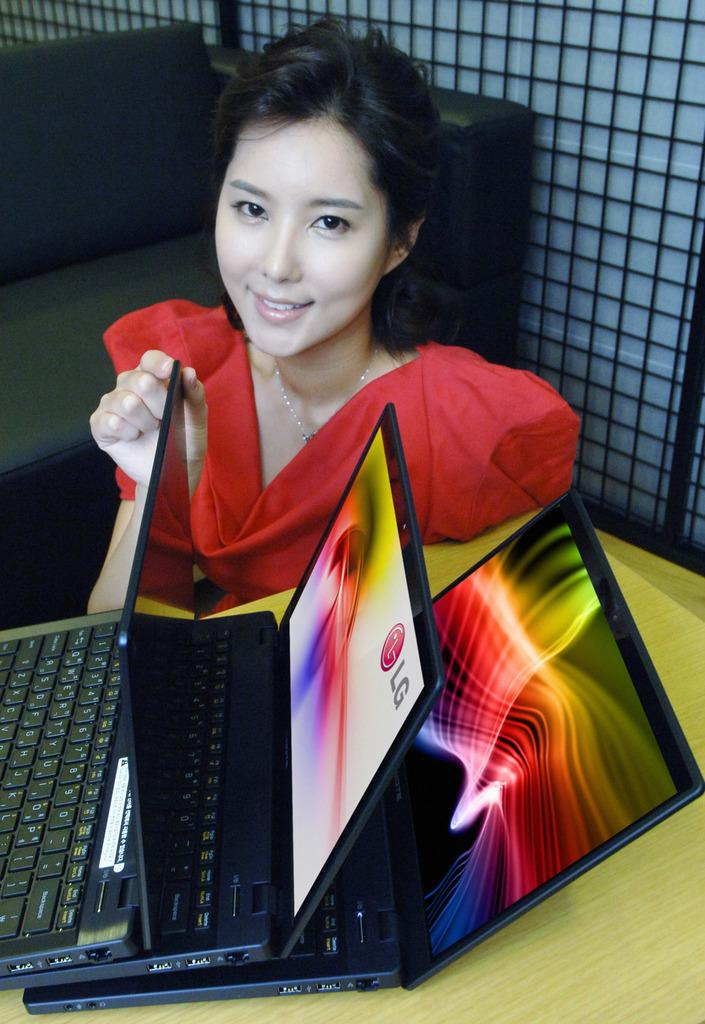What is the main subject of the image? The main subject of the image is a beautiful woman. What is the woman wearing in the image? The woman is wearing a red dress. What electronic devices can be seen in the image? There are 3 laptops in the middle of the image. What type of art can be seen hanging on the wall behind the woman in the image? There is no art visible on the wall behind the woman in the image. Can you tell me how many potatoes are on the table next to the laptops? There are no potatoes present in the image. 